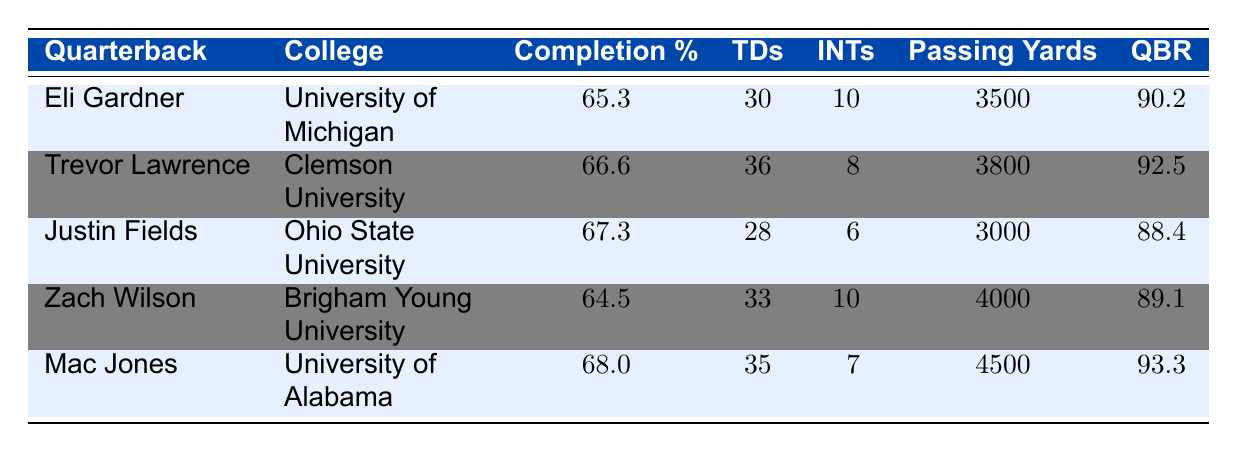What is Eli Gardner's completion percentage? Eli Gardner's completion percentage is listed in the table under the column "Completion %," which shows a value of 65.3.
Answer: 65.3 Who has the highest passing yards among the quarterbacks? By examining the "Passing Yards" column, Mac Jones has the highest value of 4500 passing yards compared to the other quarterbacks.
Answer: Mac Jones Is Eli Gardner's touchdown total greater than that of Justin Fields? Eli Gardner has 30 touchdowns while Justin Fields has 28. Since 30 is greater than 28, the statement is true.
Answer: Yes What is the average interception count of all quarterbacks listed? To find the average, sum the interceptions: (10 + 8 + 6 + 10 + 7) = 51. There are 5 quarterbacks, so the average is 51 / 5 = 10.2.
Answer: 10.2 Did any quarterback have a completion percentage below 65%? Checking the "Completion %" column, only Zach Wilson has a value of 64.5, which is below 65%. Therefore, the answer is true.
Answer: Yes Which quarterback has the best QBR? The "QBR" column shows that Mac Jones, with a QBR of 93.3, has the highest value when compared to the other quarterbacks.
Answer: Mac Jones How many total touchdowns did Eli Gardner and Mac Jones combine for? Eli Gardner has 30 touchdowns and Mac Jones has 35. Adding these together gives 30 + 35 = 65 total touchdowns for both.
Answer: 65 Which quarterback has the lowest completion percentage? In the "Completion %" column, Zach Wilson has the lowest percentage at 64.5, indicating he had the least accurate passing among the listed quarterbacks.
Answer: Zach Wilson Is it true that Trevor Lawrence had more interceptions than Eli Gardner? Trevor Lawrence threw 8 interceptions, and Eli Gardner threw 10 interceptions, which means Trevor Lawrence had fewer interceptions. Therefore, the statement is false.
Answer: No 